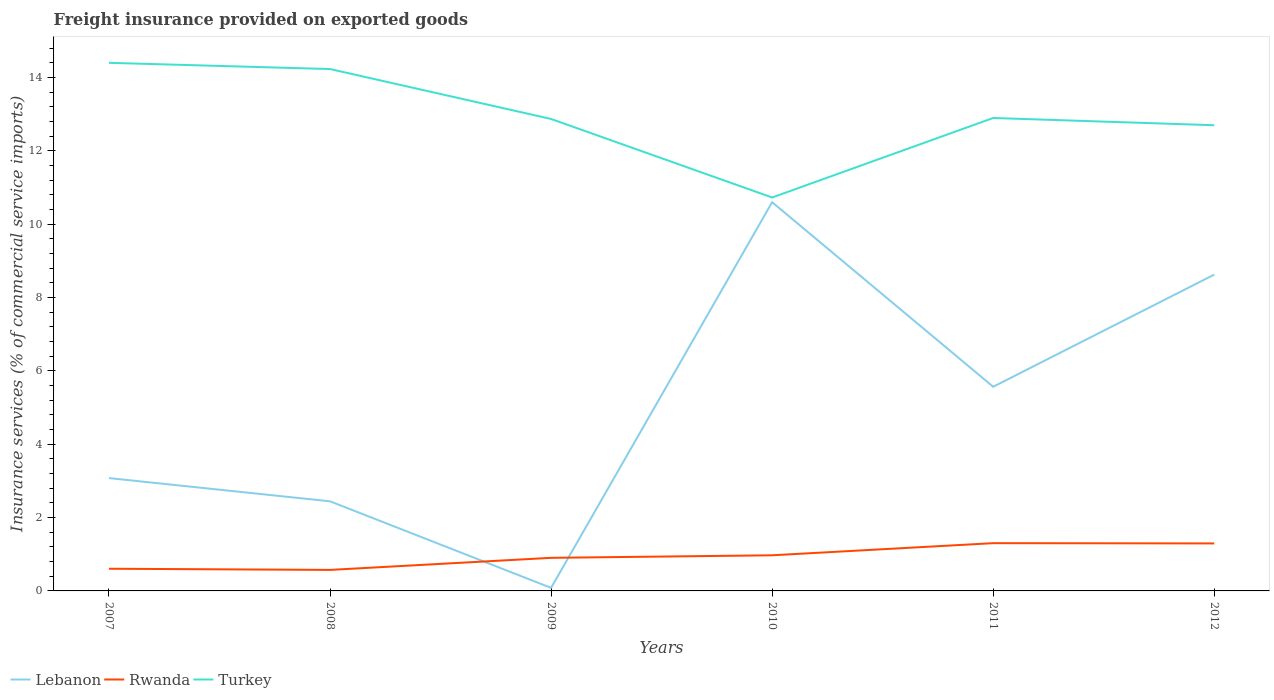Does the line corresponding to Lebanon intersect with the line corresponding to Rwanda?
Make the answer very short. Yes. Is the number of lines equal to the number of legend labels?
Provide a succinct answer. Yes. Across all years, what is the maximum freight insurance provided on exported goods in Lebanon?
Provide a succinct answer. 0.08. What is the total freight insurance provided on exported goods in Rwanda in the graph?
Give a very brief answer. -0.73. What is the difference between the highest and the second highest freight insurance provided on exported goods in Turkey?
Your answer should be compact. 3.67. What is the difference between the highest and the lowest freight insurance provided on exported goods in Turkey?
Provide a succinct answer. 2. How many lines are there?
Offer a very short reply. 3. How many years are there in the graph?
Your response must be concise. 6. What is the difference between two consecutive major ticks on the Y-axis?
Provide a succinct answer. 2. Are the values on the major ticks of Y-axis written in scientific E-notation?
Your answer should be compact. No. Does the graph contain any zero values?
Provide a succinct answer. No. Where does the legend appear in the graph?
Your response must be concise. Bottom left. How many legend labels are there?
Your response must be concise. 3. What is the title of the graph?
Offer a very short reply. Freight insurance provided on exported goods. Does "Sub-Saharan Africa (developing only)" appear as one of the legend labels in the graph?
Provide a succinct answer. No. What is the label or title of the X-axis?
Provide a short and direct response. Years. What is the label or title of the Y-axis?
Make the answer very short. Insurance services (% of commercial service imports). What is the Insurance services (% of commercial service imports) of Lebanon in 2007?
Keep it short and to the point. 3.08. What is the Insurance services (% of commercial service imports) in Rwanda in 2007?
Ensure brevity in your answer.  0.61. What is the Insurance services (% of commercial service imports) in Turkey in 2007?
Your response must be concise. 14.4. What is the Insurance services (% of commercial service imports) in Lebanon in 2008?
Provide a succinct answer. 2.44. What is the Insurance services (% of commercial service imports) of Rwanda in 2008?
Your response must be concise. 0.57. What is the Insurance services (% of commercial service imports) in Turkey in 2008?
Your answer should be compact. 14.23. What is the Insurance services (% of commercial service imports) of Lebanon in 2009?
Give a very brief answer. 0.08. What is the Insurance services (% of commercial service imports) of Rwanda in 2009?
Give a very brief answer. 0.9. What is the Insurance services (% of commercial service imports) of Turkey in 2009?
Your answer should be very brief. 12.87. What is the Insurance services (% of commercial service imports) of Lebanon in 2010?
Offer a very short reply. 10.6. What is the Insurance services (% of commercial service imports) of Rwanda in 2010?
Make the answer very short. 0.97. What is the Insurance services (% of commercial service imports) of Turkey in 2010?
Your answer should be compact. 10.73. What is the Insurance services (% of commercial service imports) of Lebanon in 2011?
Provide a succinct answer. 5.57. What is the Insurance services (% of commercial service imports) of Rwanda in 2011?
Your response must be concise. 1.3. What is the Insurance services (% of commercial service imports) in Turkey in 2011?
Your answer should be very brief. 12.9. What is the Insurance services (% of commercial service imports) in Lebanon in 2012?
Keep it short and to the point. 8.63. What is the Insurance services (% of commercial service imports) in Rwanda in 2012?
Offer a terse response. 1.3. What is the Insurance services (% of commercial service imports) in Turkey in 2012?
Offer a very short reply. 12.7. Across all years, what is the maximum Insurance services (% of commercial service imports) in Lebanon?
Provide a short and direct response. 10.6. Across all years, what is the maximum Insurance services (% of commercial service imports) of Rwanda?
Give a very brief answer. 1.3. Across all years, what is the maximum Insurance services (% of commercial service imports) of Turkey?
Your answer should be compact. 14.4. Across all years, what is the minimum Insurance services (% of commercial service imports) of Lebanon?
Offer a terse response. 0.08. Across all years, what is the minimum Insurance services (% of commercial service imports) in Rwanda?
Your answer should be compact. 0.57. Across all years, what is the minimum Insurance services (% of commercial service imports) in Turkey?
Your answer should be very brief. 10.73. What is the total Insurance services (% of commercial service imports) in Lebanon in the graph?
Make the answer very short. 30.41. What is the total Insurance services (% of commercial service imports) in Rwanda in the graph?
Offer a very short reply. 5.65. What is the total Insurance services (% of commercial service imports) in Turkey in the graph?
Ensure brevity in your answer.  77.85. What is the difference between the Insurance services (% of commercial service imports) of Lebanon in 2007 and that in 2008?
Give a very brief answer. 0.63. What is the difference between the Insurance services (% of commercial service imports) of Rwanda in 2007 and that in 2008?
Give a very brief answer. 0.03. What is the difference between the Insurance services (% of commercial service imports) of Turkey in 2007 and that in 2008?
Provide a short and direct response. 0.17. What is the difference between the Insurance services (% of commercial service imports) of Lebanon in 2007 and that in 2009?
Your answer should be compact. 2.99. What is the difference between the Insurance services (% of commercial service imports) in Rwanda in 2007 and that in 2009?
Offer a terse response. -0.3. What is the difference between the Insurance services (% of commercial service imports) in Turkey in 2007 and that in 2009?
Offer a very short reply. 1.53. What is the difference between the Insurance services (% of commercial service imports) of Lebanon in 2007 and that in 2010?
Offer a terse response. -7.53. What is the difference between the Insurance services (% of commercial service imports) of Rwanda in 2007 and that in 2010?
Offer a very short reply. -0.37. What is the difference between the Insurance services (% of commercial service imports) in Turkey in 2007 and that in 2010?
Give a very brief answer. 3.67. What is the difference between the Insurance services (% of commercial service imports) in Lebanon in 2007 and that in 2011?
Offer a terse response. -2.49. What is the difference between the Insurance services (% of commercial service imports) in Rwanda in 2007 and that in 2011?
Offer a terse response. -0.7. What is the difference between the Insurance services (% of commercial service imports) in Turkey in 2007 and that in 2011?
Your answer should be very brief. 1.5. What is the difference between the Insurance services (% of commercial service imports) of Lebanon in 2007 and that in 2012?
Ensure brevity in your answer.  -5.55. What is the difference between the Insurance services (% of commercial service imports) of Rwanda in 2007 and that in 2012?
Your response must be concise. -0.69. What is the difference between the Insurance services (% of commercial service imports) in Turkey in 2007 and that in 2012?
Make the answer very short. 1.7. What is the difference between the Insurance services (% of commercial service imports) in Lebanon in 2008 and that in 2009?
Your response must be concise. 2.36. What is the difference between the Insurance services (% of commercial service imports) in Rwanda in 2008 and that in 2009?
Your answer should be compact. -0.33. What is the difference between the Insurance services (% of commercial service imports) in Turkey in 2008 and that in 2009?
Provide a short and direct response. 1.36. What is the difference between the Insurance services (% of commercial service imports) of Lebanon in 2008 and that in 2010?
Offer a very short reply. -8.16. What is the difference between the Insurance services (% of commercial service imports) of Rwanda in 2008 and that in 2010?
Offer a very short reply. -0.4. What is the difference between the Insurance services (% of commercial service imports) in Turkey in 2008 and that in 2010?
Your response must be concise. 3.5. What is the difference between the Insurance services (% of commercial service imports) of Lebanon in 2008 and that in 2011?
Give a very brief answer. -3.12. What is the difference between the Insurance services (% of commercial service imports) of Rwanda in 2008 and that in 2011?
Keep it short and to the point. -0.73. What is the difference between the Insurance services (% of commercial service imports) of Turkey in 2008 and that in 2011?
Ensure brevity in your answer.  1.33. What is the difference between the Insurance services (% of commercial service imports) in Lebanon in 2008 and that in 2012?
Offer a terse response. -6.18. What is the difference between the Insurance services (% of commercial service imports) in Rwanda in 2008 and that in 2012?
Provide a succinct answer. -0.72. What is the difference between the Insurance services (% of commercial service imports) in Turkey in 2008 and that in 2012?
Ensure brevity in your answer.  1.53. What is the difference between the Insurance services (% of commercial service imports) of Lebanon in 2009 and that in 2010?
Provide a succinct answer. -10.52. What is the difference between the Insurance services (% of commercial service imports) of Rwanda in 2009 and that in 2010?
Your response must be concise. -0.07. What is the difference between the Insurance services (% of commercial service imports) in Turkey in 2009 and that in 2010?
Keep it short and to the point. 2.14. What is the difference between the Insurance services (% of commercial service imports) in Lebanon in 2009 and that in 2011?
Your answer should be very brief. -5.49. What is the difference between the Insurance services (% of commercial service imports) of Rwanda in 2009 and that in 2011?
Give a very brief answer. -0.4. What is the difference between the Insurance services (% of commercial service imports) of Turkey in 2009 and that in 2011?
Provide a succinct answer. -0.03. What is the difference between the Insurance services (% of commercial service imports) in Lebanon in 2009 and that in 2012?
Provide a short and direct response. -8.54. What is the difference between the Insurance services (% of commercial service imports) of Rwanda in 2009 and that in 2012?
Provide a succinct answer. -0.39. What is the difference between the Insurance services (% of commercial service imports) of Turkey in 2009 and that in 2012?
Provide a succinct answer. 0.17. What is the difference between the Insurance services (% of commercial service imports) in Lebanon in 2010 and that in 2011?
Give a very brief answer. 5.03. What is the difference between the Insurance services (% of commercial service imports) in Rwanda in 2010 and that in 2011?
Make the answer very short. -0.33. What is the difference between the Insurance services (% of commercial service imports) in Turkey in 2010 and that in 2011?
Offer a terse response. -2.17. What is the difference between the Insurance services (% of commercial service imports) in Lebanon in 2010 and that in 2012?
Offer a terse response. 1.98. What is the difference between the Insurance services (% of commercial service imports) of Rwanda in 2010 and that in 2012?
Make the answer very short. -0.32. What is the difference between the Insurance services (% of commercial service imports) in Turkey in 2010 and that in 2012?
Your answer should be very brief. -1.97. What is the difference between the Insurance services (% of commercial service imports) of Lebanon in 2011 and that in 2012?
Provide a short and direct response. -3.06. What is the difference between the Insurance services (% of commercial service imports) in Rwanda in 2011 and that in 2012?
Provide a succinct answer. 0.01. What is the difference between the Insurance services (% of commercial service imports) of Turkey in 2011 and that in 2012?
Ensure brevity in your answer.  0.2. What is the difference between the Insurance services (% of commercial service imports) in Lebanon in 2007 and the Insurance services (% of commercial service imports) in Rwanda in 2008?
Make the answer very short. 2.5. What is the difference between the Insurance services (% of commercial service imports) in Lebanon in 2007 and the Insurance services (% of commercial service imports) in Turkey in 2008?
Give a very brief answer. -11.16. What is the difference between the Insurance services (% of commercial service imports) in Rwanda in 2007 and the Insurance services (% of commercial service imports) in Turkey in 2008?
Ensure brevity in your answer.  -13.63. What is the difference between the Insurance services (% of commercial service imports) of Lebanon in 2007 and the Insurance services (% of commercial service imports) of Rwanda in 2009?
Your response must be concise. 2.17. What is the difference between the Insurance services (% of commercial service imports) of Lebanon in 2007 and the Insurance services (% of commercial service imports) of Turkey in 2009?
Provide a short and direct response. -9.8. What is the difference between the Insurance services (% of commercial service imports) of Rwanda in 2007 and the Insurance services (% of commercial service imports) of Turkey in 2009?
Provide a short and direct response. -12.27. What is the difference between the Insurance services (% of commercial service imports) of Lebanon in 2007 and the Insurance services (% of commercial service imports) of Rwanda in 2010?
Make the answer very short. 2.11. What is the difference between the Insurance services (% of commercial service imports) in Lebanon in 2007 and the Insurance services (% of commercial service imports) in Turkey in 2010?
Your answer should be very brief. -7.65. What is the difference between the Insurance services (% of commercial service imports) in Rwanda in 2007 and the Insurance services (% of commercial service imports) in Turkey in 2010?
Make the answer very short. -10.13. What is the difference between the Insurance services (% of commercial service imports) of Lebanon in 2007 and the Insurance services (% of commercial service imports) of Rwanda in 2011?
Keep it short and to the point. 1.78. What is the difference between the Insurance services (% of commercial service imports) in Lebanon in 2007 and the Insurance services (% of commercial service imports) in Turkey in 2011?
Your answer should be very brief. -9.82. What is the difference between the Insurance services (% of commercial service imports) of Rwanda in 2007 and the Insurance services (% of commercial service imports) of Turkey in 2011?
Your answer should be very brief. -12.29. What is the difference between the Insurance services (% of commercial service imports) of Lebanon in 2007 and the Insurance services (% of commercial service imports) of Rwanda in 2012?
Make the answer very short. 1.78. What is the difference between the Insurance services (% of commercial service imports) in Lebanon in 2007 and the Insurance services (% of commercial service imports) in Turkey in 2012?
Offer a terse response. -9.62. What is the difference between the Insurance services (% of commercial service imports) in Rwanda in 2007 and the Insurance services (% of commercial service imports) in Turkey in 2012?
Your response must be concise. -12.1. What is the difference between the Insurance services (% of commercial service imports) in Lebanon in 2008 and the Insurance services (% of commercial service imports) in Rwanda in 2009?
Ensure brevity in your answer.  1.54. What is the difference between the Insurance services (% of commercial service imports) in Lebanon in 2008 and the Insurance services (% of commercial service imports) in Turkey in 2009?
Provide a succinct answer. -10.43. What is the difference between the Insurance services (% of commercial service imports) in Rwanda in 2008 and the Insurance services (% of commercial service imports) in Turkey in 2009?
Keep it short and to the point. -12.3. What is the difference between the Insurance services (% of commercial service imports) of Lebanon in 2008 and the Insurance services (% of commercial service imports) of Rwanda in 2010?
Provide a short and direct response. 1.47. What is the difference between the Insurance services (% of commercial service imports) in Lebanon in 2008 and the Insurance services (% of commercial service imports) in Turkey in 2010?
Give a very brief answer. -8.29. What is the difference between the Insurance services (% of commercial service imports) of Rwanda in 2008 and the Insurance services (% of commercial service imports) of Turkey in 2010?
Provide a short and direct response. -10.16. What is the difference between the Insurance services (% of commercial service imports) of Lebanon in 2008 and the Insurance services (% of commercial service imports) of Rwanda in 2011?
Give a very brief answer. 1.14. What is the difference between the Insurance services (% of commercial service imports) in Lebanon in 2008 and the Insurance services (% of commercial service imports) in Turkey in 2011?
Your answer should be very brief. -10.46. What is the difference between the Insurance services (% of commercial service imports) in Rwanda in 2008 and the Insurance services (% of commercial service imports) in Turkey in 2011?
Provide a succinct answer. -12.33. What is the difference between the Insurance services (% of commercial service imports) in Lebanon in 2008 and the Insurance services (% of commercial service imports) in Rwanda in 2012?
Offer a very short reply. 1.15. What is the difference between the Insurance services (% of commercial service imports) of Lebanon in 2008 and the Insurance services (% of commercial service imports) of Turkey in 2012?
Offer a very short reply. -10.26. What is the difference between the Insurance services (% of commercial service imports) of Rwanda in 2008 and the Insurance services (% of commercial service imports) of Turkey in 2012?
Offer a very short reply. -12.13. What is the difference between the Insurance services (% of commercial service imports) in Lebanon in 2009 and the Insurance services (% of commercial service imports) in Rwanda in 2010?
Keep it short and to the point. -0.89. What is the difference between the Insurance services (% of commercial service imports) of Lebanon in 2009 and the Insurance services (% of commercial service imports) of Turkey in 2010?
Offer a very short reply. -10.65. What is the difference between the Insurance services (% of commercial service imports) in Rwanda in 2009 and the Insurance services (% of commercial service imports) in Turkey in 2010?
Your answer should be compact. -9.83. What is the difference between the Insurance services (% of commercial service imports) of Lebanon in 2009 and the Insurance services (% of commercial service imports) of Rwanda in 2011?
Your answer should be compact. -1.22. What is the difference between the Insurance services (% of commercial service imports) in Lebanon in 2009 and the Insurance services (% of commercial service imports) in Turkey in 2011?
Your answer should be very brief. -12.82. What is the difference between the Insurance services (% of commercial service imports) of Rwanda in 2009 and the Insurance services (% of commercial service imports) of Turkey in 2011?
Offer a terse response. -12. What is the difference between the Insurance services (% of commercial service imports) in Lebanon in 2009 and the Insurance services (% of commercial service imports) in Rwanda in 2012?
Your answer should be very brief. -1.21. What is the difference between the Insurance services (% of commercial service imports) of Lebanon in 2009 and the Insurance services (% of commercial service imports) of Turkey in 2012?
Ensure brevity in your answer.  -12.62. What is the difference between the Insurance services (% of commercial service imports) of Rwanda in 2009 and the Insurance services (% of commercial service imports) of Turkey in 2012?
Give a very brief answer. -11.8. What is the difference between the Insurance services (% of commercial service imports) in Lebanon in 2010 and the Insurance services (% of commercial service imports) in Rwanda in 2011?
Keep it short and to the point. 9.3. What is the difference between the Insurance services (% of commercial service imports) of Lebanon in 2010 and the Insurance services (% of commercial service imports) of Turkey in 2011?
Your response must be concise. -2.3. What is the difference between the Insurance services (% of commercial service imports) of Rwanda in 2010 and the Insurance services (% of commercial service imports) of Turkey in 2011?
Your answer should be very brief. -11.93. What is the difference between the Insurance services (% of commercial service imports) in Lebanon in 2010 and the Insurance services (% of commercial service imports) in Rwanda in 2012?
Give a very brief answer. 9.31. What is the difference between the Insurance services (% of commercial service imports) in Lebanon in 2010 and the Insurance services (% of commercial service imports) in Turkey in 2012?
Give a very brief answer. -2.1. What is the difference between the Insurance services (% of commercial service imports) in Rwanda in 2010 and the Insurance services (% of commercial service imports) in Turkey in 2012?
Your answer should be very brief. -11.73. What is the difference between the Insurance services (% of commercial service imports) in Lebanon in 2011 and the Insurance services (% of commercial service imports) in Rwanda in 2012?
Your response must be concise. 4.27. What is the difference between the Insurance services (% of commercial service imports) of Lebanon in 2011 and the Insurance services (% of commercial service imports) of Turkey in 2012?
Ensure brevity in your answer.  -7.13. What is the difference between the Insurance services (% of commercial service imports) in Rwanda in 2011 and the Insurance services (% of commercial service imports) in Turkey in 2012?
Ensure brevity in your answer.  -11.4. What is the average Insurance services (% of commercial service imports) in Lebanon per year?
Make the answer very short. 5.07. What is the average Insurance services (% of commercial service imports) in Rwanda per year?
Your answer should be compact. 0.94. What is the average Insurance services (% of commercial service imports) in Turkey per year?
Offer a terse response. 12.97. In the year 2007, what is the difference between the Insurance services (% of commercial service imports) in Lebanon and Insurance services (% of commercial service imports) in Rwanda?
Provide a succinct answer. 2.47. In the year 2007, what is the difference between the Insurance services (% of commercial service imports) in Lebanon and Insurance services (% of commercial service imports) in Turkey?
Your answer should be compact. -11.33. In the year 2007, what is the difference between the Insurance services (% of commercial service imports) in Rwanda and Insurance services (% of commercial service imports) in Turkey?
Offer a very short reply. -13.8. In the year 2008, what is the difference between the Insurance services (% of commercial service imports) in Lebanon and Insurance services (% of commercial service imports) in Rwanda?
Provide a short and direct response. 1.87. In the year 2008, what is the difference between the Insurance services (% of commercial service imports) in Lebanon and Insurance services (% of commercial service imports) in Turkey?
Make the answer very short. -11.79. In the year 2008, what is the difference between the Insurance services (% of commercial service imports) in Rwanda and Insurance services (% of commercial service imports) in Turkey?
Offer a very short reply. -13.66. In the year 2009, what is the difference between the Insurance services (% of commercial service imports) of Lebanon and Insurance services (% of commercial service imports) of Rwanda?
Your response must be concise. -0.82. In the year 2009, what is the difference between the Insurance services (% of commercial service imports) of Lebanon and Insurance services (% of commercial service imports) of Turkey?
Provide a succinct answer. -12.79. In the year 2009, what is the difference between the Insurance services (% of commercial service imports) in Rwanda and Insurance services (% of commercial service imports) in Turkey?
Provide a short and direct response. -11.97. In the year 2010, what is the difference between the Insurance services (% of commercial service imports) of Lebanon and Insurance services (% of commercial service imports) of Rwanda?
Give a very brief answer. 9.63. In the year 2010, what is the difference between the Insurance services (% of commercial service imports) of Lebanon and Insurance services (% of commercial service imports) of Turkey?
Give a very brief answer. -0.13. In the year 2010, what is the difference between the Insurance services (% of commercial service imports) of Rwanda and Insurance services (% of commercial service imports) of Turkey?
Provide a succinct answer. -9.76. In the year 2011, what is the difference between the Insurance services (% of commercial service imports) in Lebanon and Insurance services (% of commercial service imports) in Rwanda?
Offer a very short reply. 4.27. In the year 2011, what is the difference between the Insurance services (% of commercial service imports) in Lebanon and Insurance services (% of commercial service imports) in Turkey?
Make the answer very short. -7.33. In the year 2011, what is the difference between the Insurance services (% of commercial service imports) in Rwanda and Insurance services (% of commercial service imports) in Turkey?
Ensure brevity in your answer.  -11.6. In the year 2012, what is the difference between the Insurance services (% of commercial service imports) in Lebanon and Insurance services (% of commercial service imports) in Rwanda?
Offer a terse response. 7.33. In the year 2012, what is the difference between the Insurance services (% of commercial service imports) in Lebanon and Insurance services (% of commercial service imports) in Turkey?
Offer a very short reply. -4.07. In the year 2012, what is the difference between the Insurance services (% of commercial service imports) of Rwanda and Insurance services (% of commercial service imports) of Turkey?
Provide a succinct answer. -11.41. What is the ratio of the Insurance services (% of commercial service imports) of Lebanon in 2007 to that in 2008?
Offer a very short reply. 1.26. What is the ratio of the Insurance services (% of commercial service imports) of Rwanda in 2007 to that in 2008?
Your response must be concise. 1.06. What is the ratio of the Insurance services (% of commercial service imports) in Turkey in 2007 to that in 2008?
Your answer should be compact. 1.01. What is the ratio of the Insurance services (% of commercial service imports) in Lebanon in 2007 to that in 2009?
Your answer should be compact. 36.8. What is the ratio of the Insurance services (% of commercial service imports) of Rwanda in 2007 to that in 2009?
Your answer should be very brief. 0.67. What is the ratio of the Insurance services (% of commercial service imports) in Turkey in 2007 to that in 2009?
Give a very brief answer. 1.12. What is the ratio of the Insurance services (% of commercial service imports) of Lebanon in 2007 to that in 2010?
Provide a succinct answer. 0.29. What is the ratio of the Insurance services (% of commercial service imports) in Rwanda in 2007 to that in 2010?
Make the answer very short. 0.62. What is the ratio of the Insurance services (% of commercial service imports) in Turkey in 2007 to that in 2010?
Provide a short and direct response. 1.34. What is the ratio of the Insurance services (% of commercial service imports) in Lebanon in 2007 to that in 2011?
Make the answer very short. 0.55. What is the ratio of the Insurance services (% of commercial service imports) of Rwanda in 2007 to that in 2011?
Your answer should be compact. 0.46. What is the ratio of the Insurance services (% of commercial service imports) of Turkey in 2007 to that in 2011?
Ensure brevity in your answer.  1.12. What is the ratio of the Insurance services (% of commercial service imports) in Lebanon in 2007 to that in 2012?
Ensure brevity in your answer.  0.36. What is the ratio of the Insurance services (% of commercial service imports) of Rwanda in 2007 to that in 2012?
Give a very brief answer. 0.47. What is the ratio of the Insurance services (% of commercial service imports) of Turkey in 2007 to that in 2012?
Give a very brief answer. 1.13. What is the ratio of the Insurance services (% of commercial service imports) of Lebanon in 2008 to that in 2009?
Keep it short and to the point. 29.23. What is the ratio of the Insurance services (% of commercial service imports) in Rwanda in 2008 to that in 2009?
Provide a short and direct response. 0.64. What is the ratio of the Insurance services (% of commercial service imports) in Turkey in 2008 to that in 2009?
Offer a very short reply. 1.11. What is the ratio of the Insurance services (% of commercial service imports) of Lebanon in 2008 to that in 2010?
Give a very brief answer. 0.23. What is the ratio of the Insurance services (% of commercial service imports) in Rwanda in 2008 to that in 2010?
Make the answer very short. 0.59. What is the ratio of the Insurance services (% of commercial service imports) of Turkey in 2008 to that in 2010?
Give a very brief answer. 1.33. What is the ratio of the Insurance services (% of commercial service imports) in Lebanon in 2008 to that in 2011?
Give a very brief answer. 0.44. What is the ratio of the Insurance services (% of commercial service imports) in Rwanda in 2008 to that in 2011?
Your answer should be very brief. 0.44. What is the ratio of the Insurance services (% of commercial service imports) in Turkey in 2008 to that in 2011?
Your answer should be very brief. 1.1. What is the ratio of the Insurance services (% of commercial service imports) in Lebanon in 2008 to that in 2012?
Offer a very short reply. 0.28. What is the ratio of the Insurance services (% of commercial service imports) in Rwanda in 2008 to that in 2012?
Offer a very short reply. 0.44. What is the ratio of the Insurance services (% of commercial service imports) in Turkey in 2008 to that in 2012?
Keep it short and to the point. 1.12. What is the ratio of the Insurance services (% of commercial service imports) in Lebanon in 2009 to that in 2010?
Offer a terse response. 0.01. What is the ratio of the Insurance services (% of commercial service imports) in Rwanda in 2009 to that in 2010?
Provide a short and direct response. 0.93. What is the ratio of the Insurance services (% of commercial service imports) in Turkey in 2009 to that in 2010?
Your response must be concise. 1.2. What is the ratio of the Insurance services (% of commercial service imports) in Lebanon in 2009 to that in 2011?
Provide a succinct answer. 0.01. What is the ratio of the Insurance services (% of commercial service imports) of Rwanda in 2009 to that in 2011?
Ensure brevity in your answer.  0.69. What is the ratio of the Insurance services (% of commercial service imports) of Turkey in 2009 to that in 2011?
Provide a succinct answer. 1. What is the ratio of the Insurance services (% of commercial service imports) of Lebanon in 2009 to that in 2012?
Offer a terse response. 0.01. What is the ratio of the Insurance services (% of commercial service imports) of Rwanda in 2009 to that in 2012?
Make the answer very short. 0.7. What is the ratio of the Insurance services (% of commercial service imports) in Turkey in 2009 to that in 2012?
Provide a short and direct response. 1.01. What is the ratio of the Insurance services (% of commercial service imports) in Lebanon in 2010 to that in 2011?
Make the answer very short. 1.9. What is the ratio of the Insurance services (% of commercial service imports) in Rwanda in 2010 to that in 2011?
Provide a succinct answer. 0.75. What is the ratio of the Insurance services (% of commercial service imports) of Turkey in 2010 to that in 2011?
Your answer should be compact. 0.83. What is the ratio of the Insurance services (% of commercial service imports) of Lebanon in 2010 to that in 2012?
Make the answer very short. 1.23. What is the ratio of the Insurance services (% of commercial service imports) of Rwanda in 2010 to that in 2012?
Your answer should be very brief. 0.75. What is the ratio of the Insurance services (% of commercial service imports) in Turkey in 2010 to that in 2012?
Give a very brief answer. 0.84. What is the ratio of the Insurance services (% of commercial service imports) in Lebanon in 2011 to that in 2012?
Make the answer very short. 0.65. What is the ratio of the Insurance services (% of commercial service imports) in Rwanda in 2011 to that in 2012?
Your answer should be very brief. 1.01. What is the ratio of the Insurance services (% of commercial service imports) of Turkey in 2011 to that in 2012?
Your response must be concise. 1.02. What is the difference between the highest and the second highest Insurance services (% of commercial service imports) in Lebanon?
Offer a terse response. 1.98. What is the difference between the highest and the second highest Insurance services (% of commercial service imports) of Rwanda?
Give a very brief answer. 0.01. What is the difference between the highest and the second highest Insurance services (% of commercial service imports) of Turkey?
Keep it short and to the point. 0.17. What is the difference between the highest and the lowest Insurance services (% of commercial service imports) of Lebanon?
Provide a succinct answer. 10.52. What is the difference between the highest and the lowest Insurance services (% of commercial service imports) in Rwanda?
Your answer should be compact. 0.73. What is the difference between the highest and the lowest Insurance services (% of commercial service imports) of Turkey?
Your response must be concise. 3.67. 